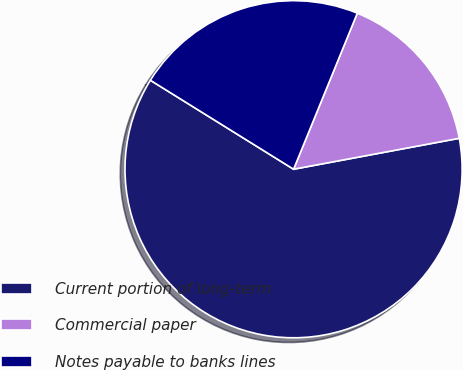Convert chart. <chart><loc_0><loc_0><loc_500><loc_500><pie_chart><fcel>Current portion of long-term<fcel>Commercial paper<fcel>Notes payable to banks lines<nl><fcel>61.78%<fcel>15.89%<fcel>22.32%<nl></chart> 